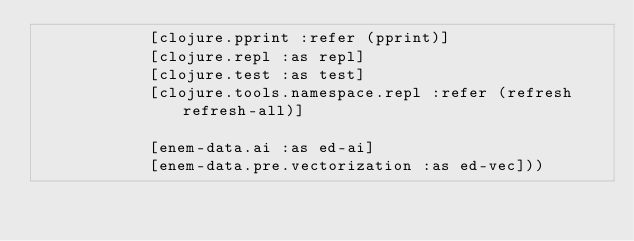Convert code to text. <code><loc_0><loc_0><loc_500><loc_500><_Clojure_>            [clojure.pprint :refer (pprint)]
            [clojure.repl :as repl]
            [clojure.test :as test]
            [clojure.tools.namespace.repl :refer (refresh refresh-all)]

            [enem-data.ai :as ed-ai]
            [enem-data.pre.vectorization :as ed-vec]))

</code> 